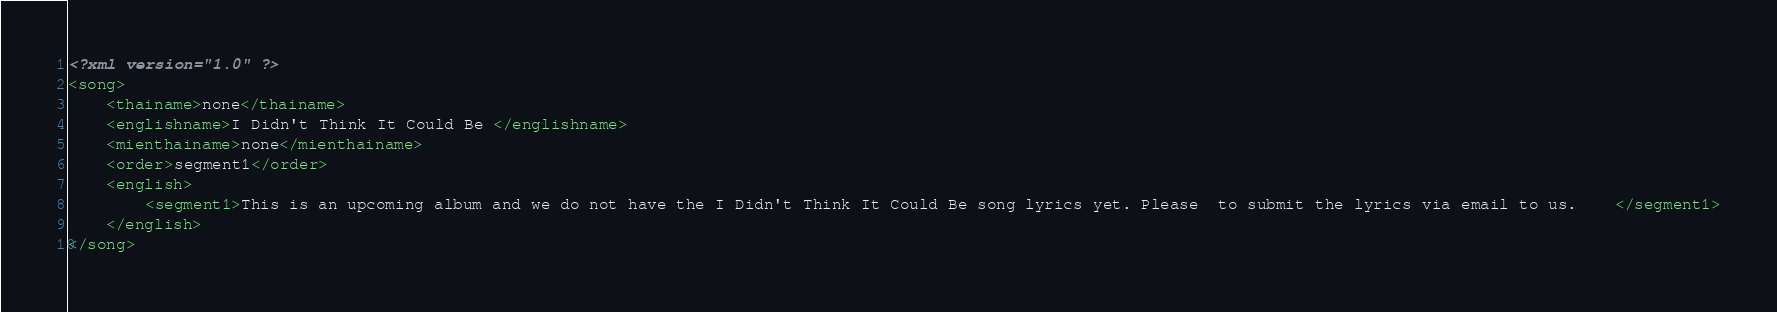<code> <loc_0><loc_0><loc_500><loc_500><_XML_><?xml version="1.0" ?>
<song>
	<thainame>none</thainame>
	<englishname>I Didn't Think It Could Be </englishname>
	<mienthainame>none</mienthainame>
	<order>segment1</order>
	<english>
		<segment1>This is an upcoming album and we do not have the I Didn't Think It Could Be song lyrics yet. Please  to submit the lyrics via email to us.    </segment1>
	</english>
</song>
</code> 